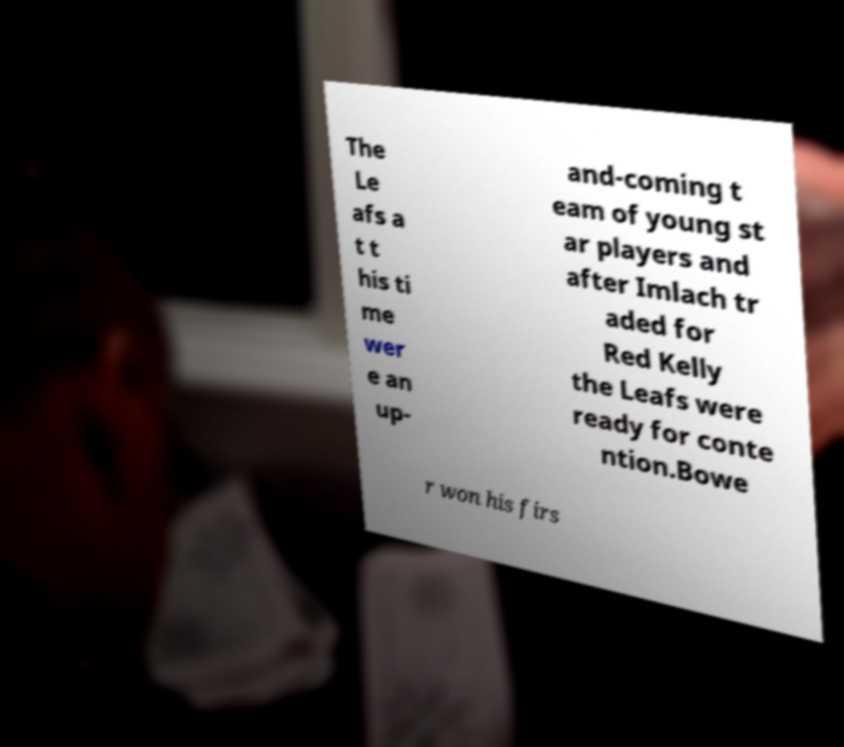What messages or text are displayed in this image? I need them in a readable, typed format. The Le afs a t t his ti me wer e an up- and-coming t eam of young st ar players and after Imlach tr aded for Red Kelly the Leafs were ready for conte ntion.Bowe r won his firs 